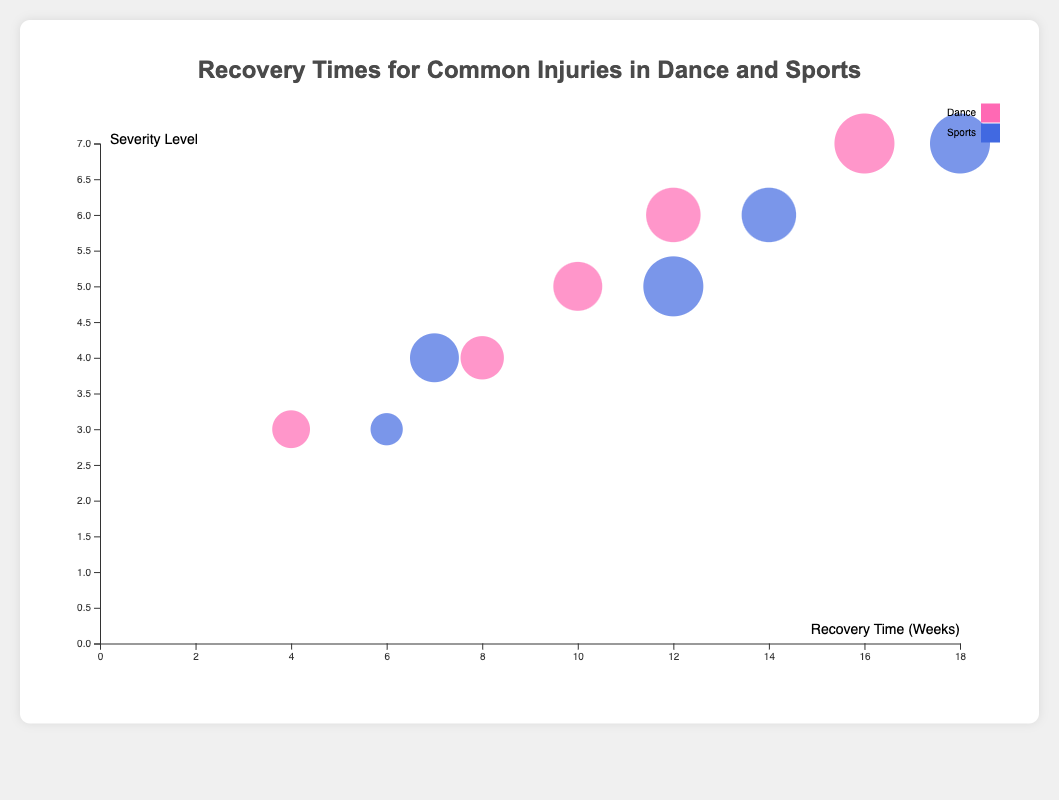How many data points are there for each category? There are two categories: Dance and Sports. By looking at the figure, we can count the number of colored bubbles for each category. There are 5 bubbles for Dance and 5 bubbles for Sports.
Answer: 5 for Dance, 5 for Sports Which injury has the highest recovery time in Sports? The x-axis represents recovery time in weeks. The bubble farthest to the right for the Sports category represents the highest recovery time. The bubble for "Knee Injury" is at 18 weeks.
Answer: Knee Injury What is the difference in recovery time for Achilles Tendonitis between Dance and Sports? Locate the bubbles for Achilles Tendonitis in both Dance and Sports categories. The recovery time for Dance is 10 weeks, and for Sports, it is 12 weeks. The difference is 12 - 10.
Answer: 2 weeks Which injury has the highest severity level in Dance? The y-axis represents the severity level. The bubble highest on the y-axis for the Dance category shows the highest severity level. The bubble for "Knee Injury" is at a severity level of 7.
Answer: Knee Injury Compare the physical impact scores for Ankle Sprain between Dance and Sports; which is higher? Look at the size of the bubbles for Ankle Sprain in both Dance and Sports categories. The physical impact score for Dance is 5 and for Sports, it is 4.
Answer: Dance What is the average recovery time for injuries in Dance? Sum the recovery times for all Dance injuries and divide by the number of injuries. (10 + 4 + 8 + 12 + 16) = 50. The average is 50/5.
Answer: 10 weeks Is the severity level for Hamstring Strain the same in Dance and Sports? Compare the positions on the y-axis for Hamstring Strain in both categories. Both bubbles are on the same height, which indicated a severity level of 4.
Answer: Yes Which category generally has larger bubbles, indicating higher physical impact scores? The size of the bubbles represents the physical impact score. In comparison, Sports bubbles tend to be larger than Dance bubbles. This indicates higher physical impact scores in general for Sports.
Answer: Sports Which injury takes the longest to recover from across both categories? Look for the bubble farthest to the right overall. The furthest right bubble is "Knee Injury" in the Sports category with a recovery time of 18 weeks.
Answer: Knee Injury Compare the severity levels for Stress Fracture between Dance and Sports. Are they equal? Compare the positions on the y-axis for Stress Fracture in both Dance and Sports to determine the severity level. Both are at the same height which indicates a severity level of 6.
Answer: Yes 